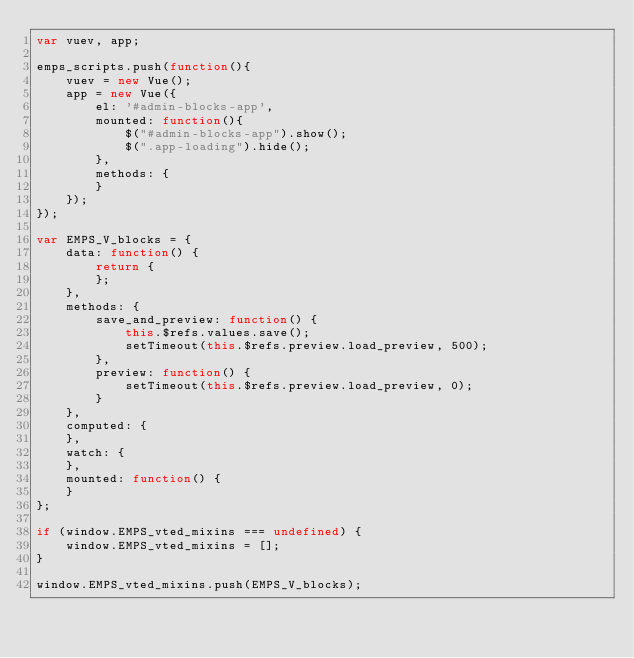Convert code to text. <code><loc_0><loc_0><loc_500><loc_500><_JavaScript_>var vuev, app;

emps_scripts.push(function(){
    vuev = new Vue();
    app = new Vue({
        el: '#admin-blocks-app',
        mounted: function(){
            $("#admin-blocks-app").show();
            $(".app-loading").hide();
        },
        methods: {
        }
    });
});

var EMPS_V_blocks = {
    data: function() {
        return {
        };
    },
    methods: {
        save_and_preview: function() {
            this.$refs.values.save();
            setTimeout(this.$refs.preview.load_preview, 500);
        },
        preview: function() {
            setTimeout(this.$refs.preview.load_preview, 0);
        }
    },
    computed: {
    },
    watch: {
    },
    mounted: function() {
    }
};

if (window.EMPS_vted_mixins === undefined) {
    window.EMPS_vted_mixins = [];
}

window.EMPS_vted_mixins.push(EMPS_V_blocks);</code> 